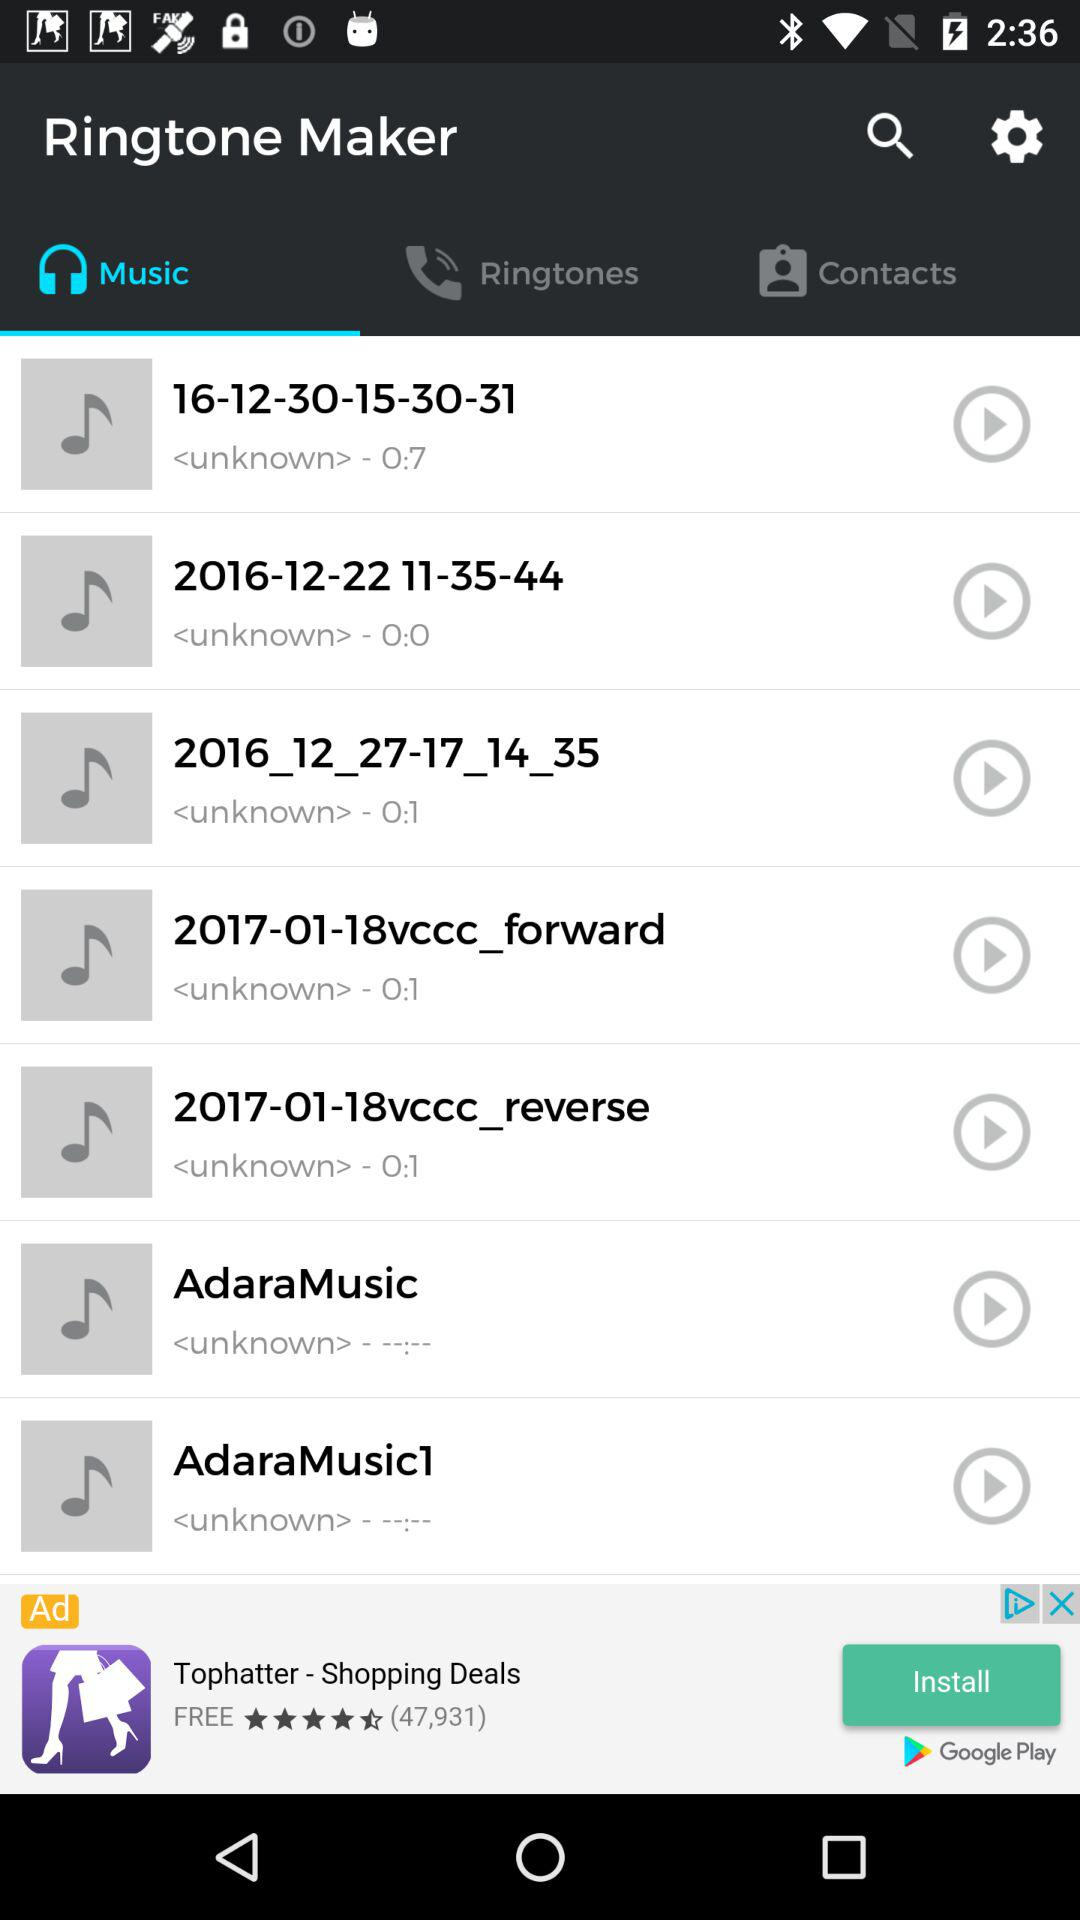What are the track available on the list? The available tracks are "16-12-30-15-30-31", "2016-12-22 11-35-44", "2016_12_27-17_14_35", "2017-01-18vccc_forward", "2017-01-18vccc_reverse", "AdaraMusic" and "AdaraMusic1". 